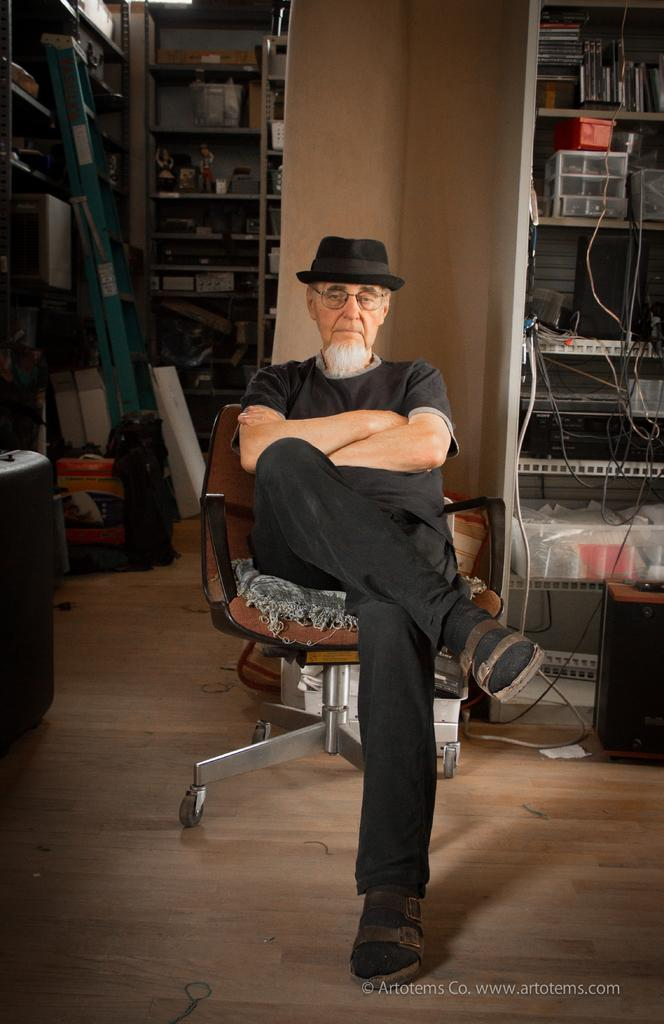Who is present in the image? There is a man in the image. What is the man doing in the image? The man is sitting on a chair. What can be seen in the background of the image? Electrical stuff is visible in the background. Where is the electrical stuff located in the image? The electrical stuff is kept on a shelf. What type of competition is the man participating in, as seen in the image? There is no competition visible in the image; it only shows a man sitting on a chair with electrical stuff in the background. 